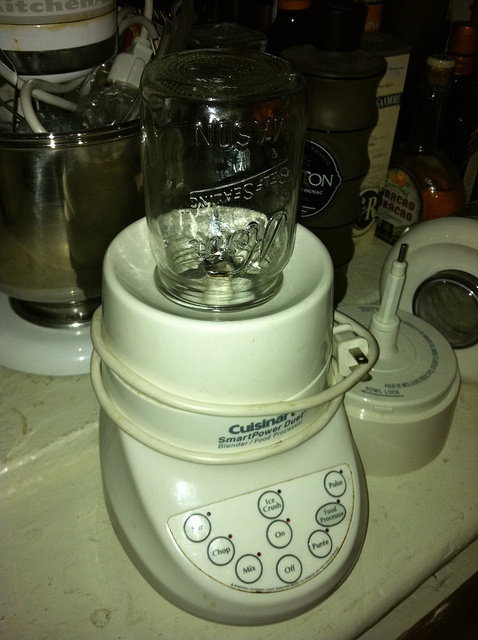Describe the objects in this image and their specific colors. I can see cup in darkgreen, black, gray, and olive tones and bottle in darkgreen, black, and maroon tones in this image. 